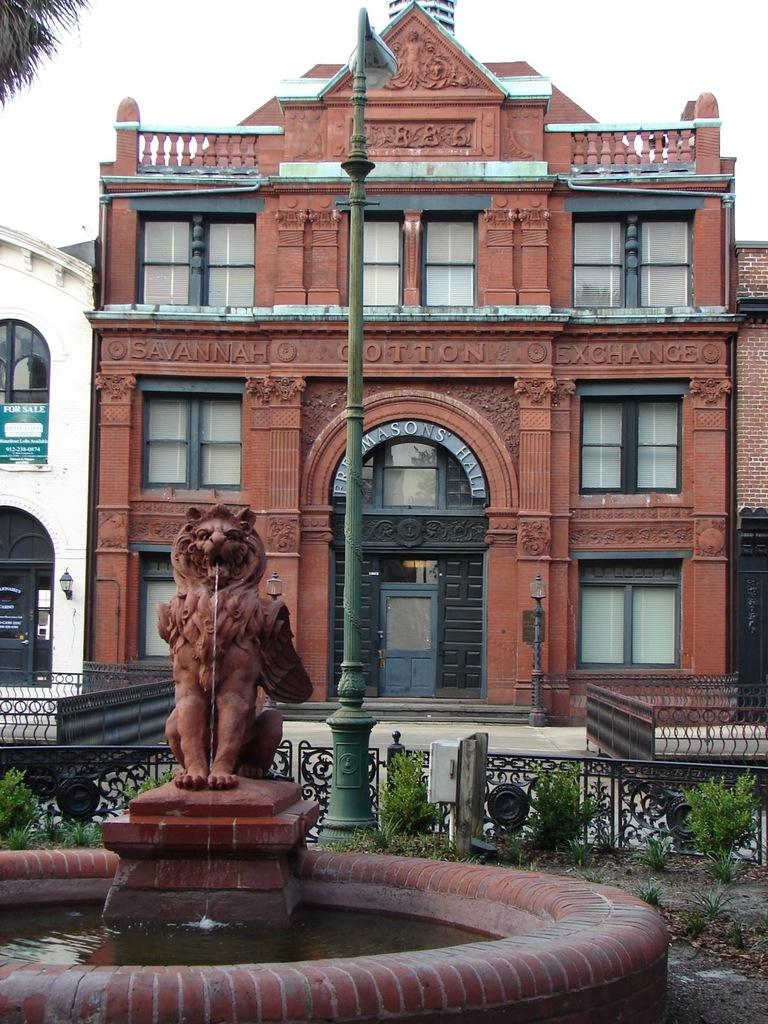What is the main subject in the image? There is a statue in the image. What can be seen in the background of the image? There is water visible in the image. What type of barrier is present in the image? There is a fence in the image. What is the pole supporting in the image? The pole is in front of a building. What type of vegetation is near the building? There is a tree beside the building. What type of instrument is being played in the afternoon in the image? There is no instrument or indication of time of day in the image; it features a statue, water, fence, pole, building, and tree. 